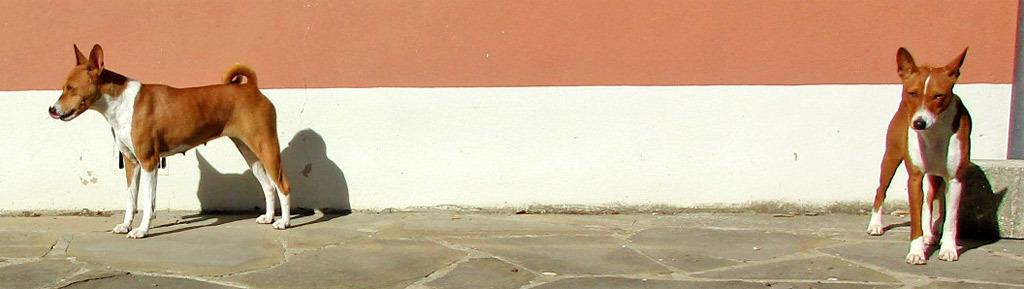What type of animals are present in the image? There are dogs in the image. Where are the dogs located in the image? The dogs are standing on the floor. What type of corn is being used by the actor in the image? There is no corn or actor present in the image; it features dogs standing on the floor. 